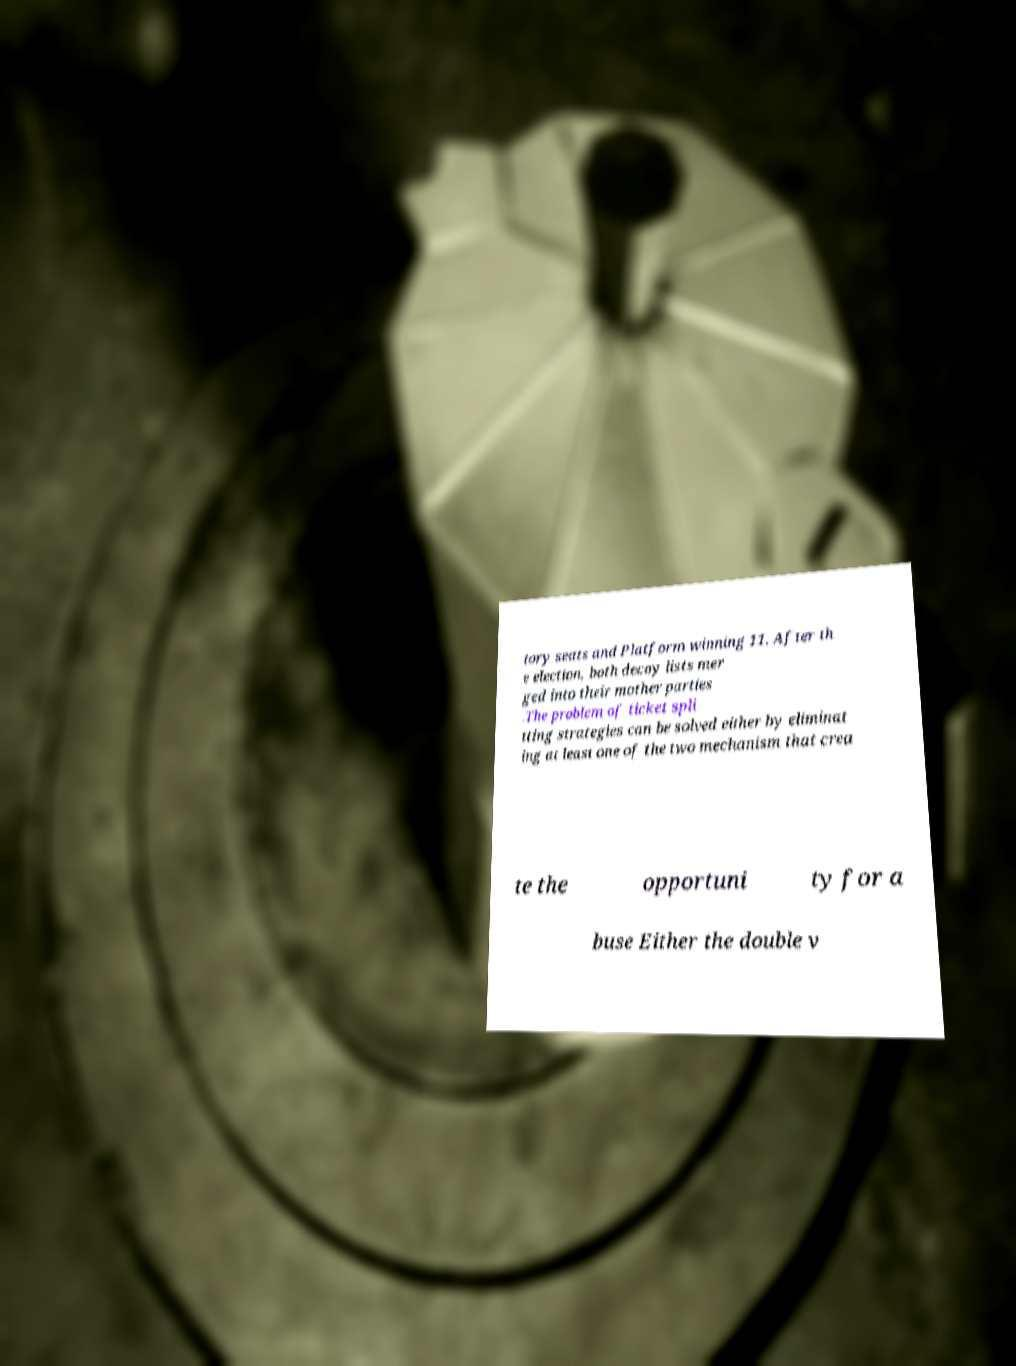Could you assist in decoding the text presented in this image and type it out clearly? tory seats and Platform winning 11. After th e election, both decoy lists mer ged into their mother parties .The problem of ticket spli tting strategies can be solved either by eliminat ing at least one of the two mechanism that crea te the opportuni ty for a buse Either the double v 